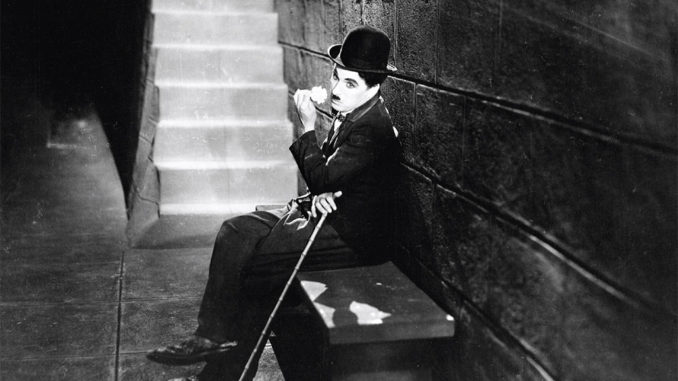How does the choice of lighting in this photograph contribute to the mood of the scene? The use of shadow and soft lighting in the photograph accentuates a dramatic and introspective mood. The shadows cast by the staircase and over Chaplin’s face highlight the internal struggles and societal isolation of his character, anchoring the Tramp's persona as a sympathetic everyman within a challenging urban landscape. 